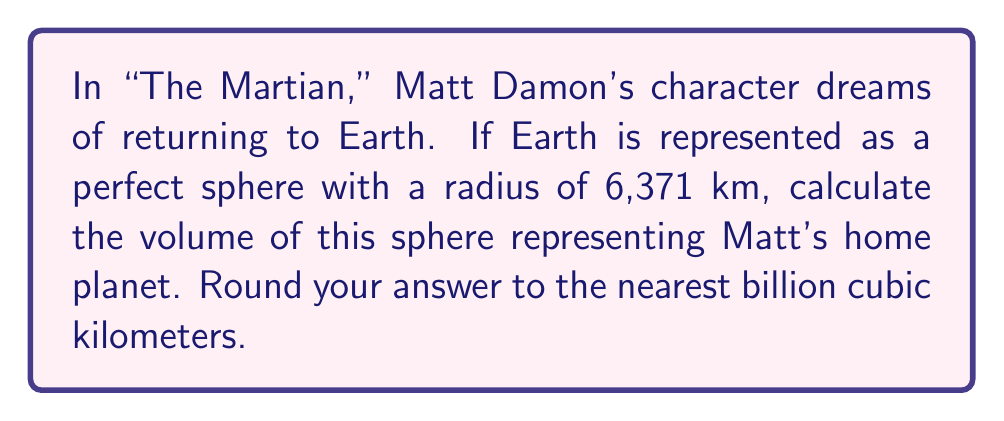Show me your answer to this math problem. To calculate the volume of a sphere, we use the formula:

$$V = \frac{4}{3}\pi r^3$$

Where:
$V$ = volume of the sphere
$r$ = radius of the sphere

Given:
$r = 6,371$ km

Let's substitute this into our formula:

$$V = \frac{4}{3}\pi (6,371)^3$$

$$V = \frac{4}{3}\pi \cdot 258,186,418,891$$

$$V = 1,083,206,916,845\pi$$

Using $\pi \approx 3.14159$, we get:

$$V \approx 1,083,206,916,845 \cdot 3.14159$$

$$V \approx 3,402,824,083,055 \text{ km}^3$$

Rounding to the nearest billion cubic kilometers:

$$V \approx 3,403,000,000,000 \text{ km}^3$$

This can be expressed as 1,083 billion cubic kilometers.
Answer: 1,083 billion km³ 